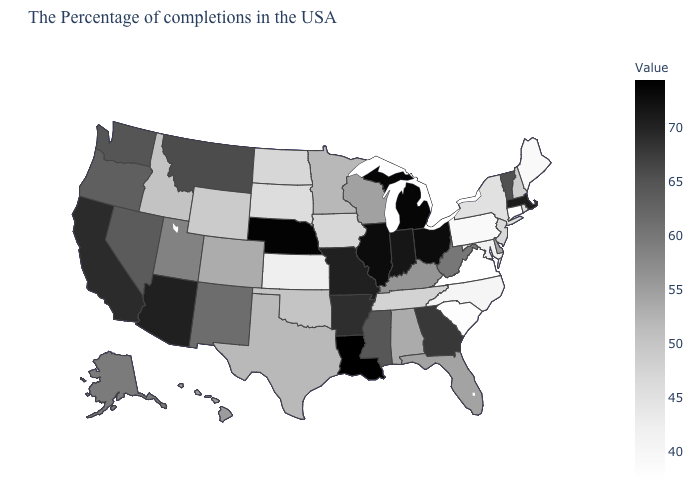Which states hav the highest value in the West?
Be succinct. Arizona. Does the map have missing data?
Quick response, please. No. Which states have the highest value in the USA?
Give a very brief answer. Louisiana. Does California have a lower value than Nebraska?
Answer briefly. Yes. Among the states that border Connecticut , does Massachusetts have the highest value?
Answer briefly. Yes. Does South Dakota have the highest value in the USA?
Give a very brief answer. No. 